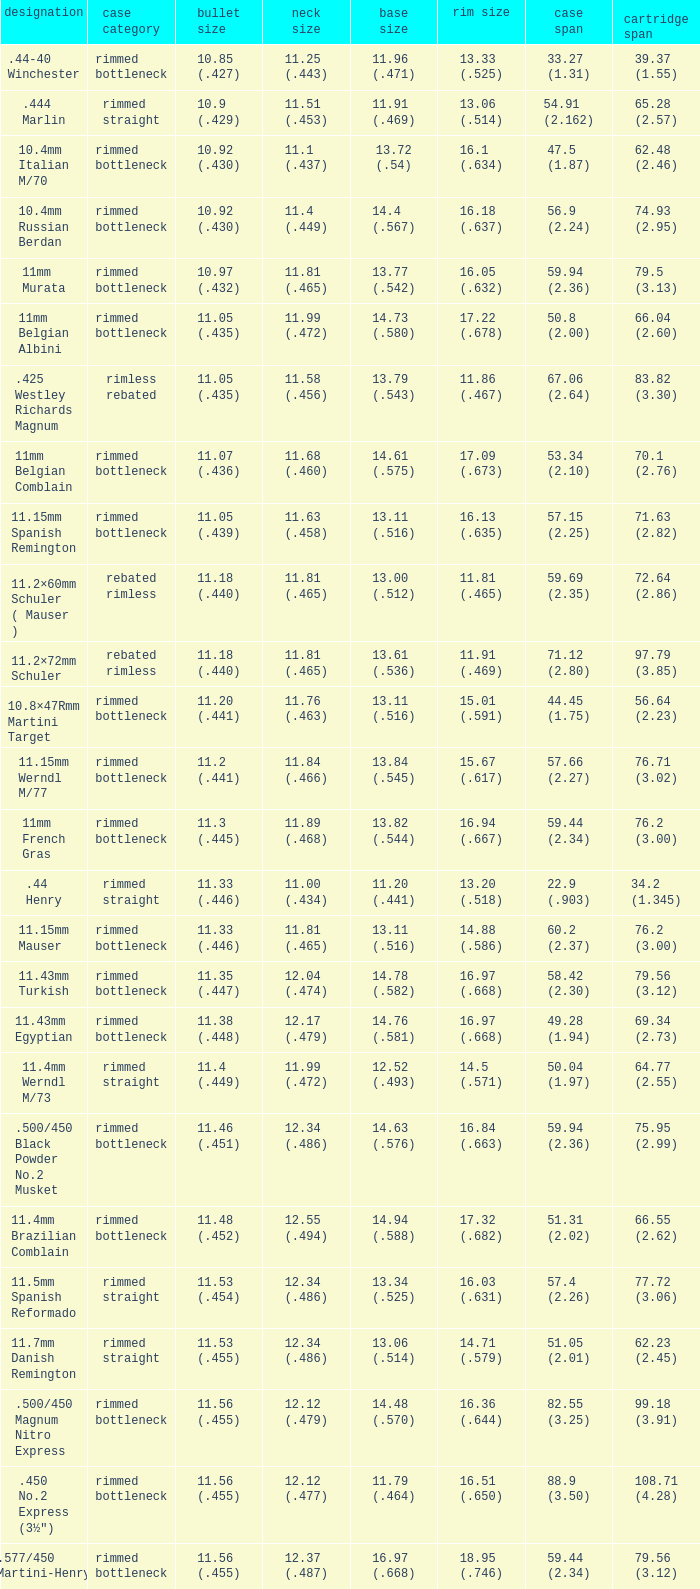Which Case length has a Rim diameter of 13.20 (.518)? 22.9 (.903). Write the full table. {'header': ['designation', 'case category', 'bullet size', 'neck size', 'base size', 'rim size', 'case span', 'cartridge span'], 'rows': [['.44-40 Winchester', 'rimmed bottleneck', '10.85 (.427)', '11.25 (.443)', '11.96 (.471)', '13.33 (.525)', '33.27 (1.31)', '39.37 (1.55)'], ['.444 Marlin', 'rimmed straight', '10.9 (.429)', '11.51 (.453)', '11.91 (.469)', '13.06 (.514)', '54.91 (2.162)', '65.28 (2.57)'], ['10.4mm Italian M/70', 'rimmed bottleneck', '10.92 (.430)', '11.1 (.437)', '13.72 (.54)', '16.1 (.634)', '47.5 (1.87)', '62.48 (2.46)'], ['10.4mm Russian Berdan', 'rimmed bottleneck', '10.92 (.430)', '11.4 (.449)', '14.4 (.567)', '16.18 (.637)', '56.9 (2.24)', '74.93 (2.95)'], ['11mm Murata', 'rimmed bottleneck', '10.97 (.432)', '11.81 (.465)', '13.77 (.542)', '16.05 (.632)', '59.94 (2.36)', '79.5 (3.13)'], ['11mm Belgian Albini', 'rimmed bottleneck', '11.05 (.435)', '11.99 (.472)', '14.73 (.580)', '17.22 (.678)', '50.8 (2.00)', '66.04 (2.60)'], ['.425 Westley Richards Magnum', 'rimless rebated', '11.05 (.435)', '11.58 (.456)', '13.79 (.543)', '11.86 (.467)', '67.06 (2.64)', '83.82 (3.30)'], ['11mm Belgian Comblain', 'rimmed bottleneck', '11.07 (.436)', '11.68 (.460)', '14.61 (.575)', '17.09 (.673)', '53.34 (2.10)', '70.1 (2.76)'], ['11.15mm Spanish Remington', 'rimmed bottleneck', '11.05 (.439)', '11.63 (.458)', '13.11 (.516)', '16.13 (.635)', '57.15 (2.25)', '71.63 (2.82)'], ['11.2×60mm Schuler ( Mauser )', 'rebated rimless', '11.18 (.440)', '11.81 (.465)', '13.00 (.512)', '11.81 (.465)', '59.69 (2.35)', '72.64 (2.86)'], ['11.2×72mm Schuler', 'rebated rimless', '11.18 (.440)', '11.81 (.465)', '13.61 (.536)', '11.91 (.469)', '71.12 (2.80)', '97.79 (3.85)'], ['10.8×47Rmm Martini Target', 'rimmed bottleneck', '11.20 (.441)', '11.76 (.463)', '13.11 (.516)', '15.01 (.591)', '44.45 (1.75)', '56.64 (2.23)'], ['11.15mm Werndl M/77', 'rimmed bottleneck', '11.2 (.441)', '11.84 (.466)', '13.84 (.545)', '15.67 (.617)', '57.66 (2.27)', '76.71 (3.02)'], ['11mm French Gras', 'rimmed bottleneck', '11.3 (.445)', '11.89 (.468)', '13.82 (.544)', '16.94 (.667)', '59.44 (2.34)', '76.2 (3.00)'], ['.44 Henry', 'rimmed straight', '11.33 (.446)', '11.00 (.434)', '11.20 (.441)', '13.20 (.518)', '22.9 (.903)', '34.2 (1.345)'], ['11.15mm Mauser', 'rimmed bottleneck', '11.33 (.446)', '11.81 (.465)', '13.11 (.516)', '14.88 (.586)', '60.2 (2.37)', '76.2 (3.00)'], ['11.43mm Turkish', 'rimmed bottleneck', '11.35 (.447)', '12.04 (.474)', '14.78 (.582)', '16.97 (.668)', '58.42 (2.30)', '79.56 (3.12)'], ['11.43mm Egyptian', 'rimmed bottleneck', '11.38 (.448)', '12.17 (.479)', '14.76 (.581)', '16.97 (.668)', '49.28 (1.94)', '69.34 (2.73)'], ['11.4mm Werndl M/73', 'rimmed straight', '11.4 (.449)', '11.99 (.472)', '12.52 (.493)', '14.5 (.571)', '50.04 (1.97)', '64.77 (2.55)'], ['.500/450 Black Powder No.2 Musket', 'rimmed bottleneck', '11.46 (.451)', '12.34 (.486)', '14.63 (.576)', '16.84 (.663)', '59.94 (2.36)', '75.95 (2.99)'], ['11.4mm Brazilian Comblain', 'rimmed bottleneck', '11.48 (.452)', '12.55 (.494)', '14.94 (.588)', '17.32 (.682)', '51.31 (2.02)', '66.55 (2.62)'], ['11.5mm Spanish Reformado', 'rimmed straight', '11.53 (.454)', '12.34 (.486)', '13.34 (.525)', '16.03 (.631)', '57.4 (2.26)', '77.72 (3.06)'], ['11.7mm Danish Remington', 'rimmed straight', '11.53 (.455)', '12.34 (.486)', '13.06 (.514)', '14.71 (.579)', '51.05 (2.01)', '62.23 (2.45)'], ['.500/450 Magnum Nitro Express', 'rimmed bottleneck', '11.56 (.455)', '12.12 (.479)', '14.48 (.570)', '16.36 (.644)', '82.55 (3.25)', '99.18 (3.91)'], ['.450 No.2 Express (3½")', 'rimmed bottleneck', '11.56 (.455)', '12.12 (.477)', '11.79 (.464)', '16.51 (.650)', '88.9 (3.50)', '108.71 (4.28)'], ['.577/450 Martini-Henry', 'rimmed bottleneck', '11.56 (.455)', '12.37 (.487)', '16.97 (.668)', '18.95 (.746)', '59.44 (2.34)', '79.56 (3.12)'], ['.45-70 Government', 'rimmed straight', '11.63 (.457)', '12.07 (.475)', '12.7 (.500)', '15.24 (.600)', '53.34 (2.1)', '68.58 (2.7)'], ['.450 Marlin', 'belted straight', '11.63 (.458)', '12.14 (.478)', '13.03 (.513)', '13.51 (.532)', '53.34 (2.100)', '64.77 (2.550)'], ['11mm Beaumont M/71/78', 'rimmed bottleneck', '11.63 (.457)', '12.29 (.484)', '14.63 (.576)', '16.89 (.665)', '51.82 (2.04)', '64.52 (2.54)'], ['.450 Nitro Express (3¼")', 'rimmed straight', '11.63 (.458)', '12.12 (.479)', '13.92 (.548)', '15.9 (.626)', '82.55 (3.25)', '97.79 (3.85)'], ['.458 Winchester Magnum', 'belted straight', '11.63 (.458)', '12.14 (.478)', '13.03 (.513)', '13.51 (.532)', '63.5 (2.5)', '82.55 (3.350)'], ['.460 Weatherby Magnum', 'belted bottleneck', '11.63 (.458)', '12.32 (.485)', '14.80 (.583)', '13.54 (.533)', '74 (2.91)', '95.25 (3.75)'], ['.500/450 No.1 Express', 'rimmed bottleneck', '11.63 (.458)', '12.32 (.485)', '14.66 (.577)', '16.76 (.660)', '69.85 (2.75)', '82.55 (3.25)'], ['.450 Rigby Rimless', 'rimless bottleneck', '11.63 (.458)', '12.38 (.487)', '14.66 (.577)', '14.99 (.590)', '73.50 (2.89)', '95.00 (3.74)'], ['11.3mm Beaumont M/71', 'rimmed bottleneck', '11.63 (.464)', '12.34 (.486)', '14.76 (.581)', '16.92 (.666)', '50.04 (1.97)', '63.25 (2.49)'], ['.500/465 Nitro Express', 'rimmed bottleneck', '11.84 (.466)', '12.39 (.488)', '14.55 (.573)', '16.51 (.650)', '82.3 (3.24)', '98.04 (3.89)']]} 